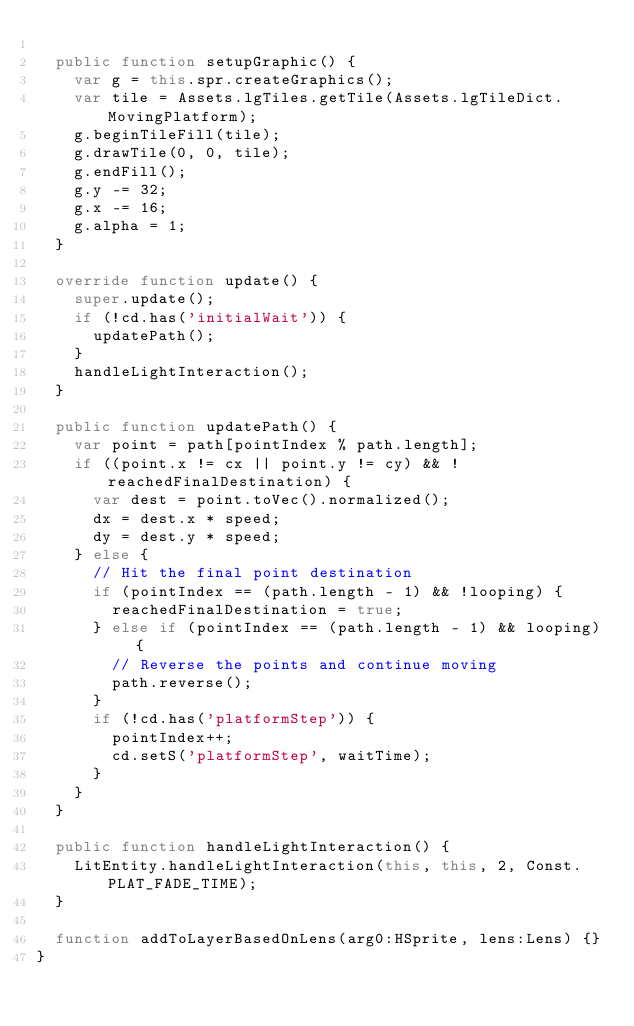Convert code to text. <code><loc_0><loc_0><loc_500><loc_500><_Haxe_>
  public function setupGraphic() {
    var g = this.spr.createGraphics();
    var tile = Assets.lgTiles.getTile(Assets.lgTileDict.MovingPlatform);
    g.beginTileFill(tile);
    g.drawTile(0, 0, tile);
    g.endFill();
    g.y -= 32;
    g.x -= 16;
    g.alpha = 1;
  }

  override function update() {
    super.update();
    if (!cd.has('initialWait')) {
      updatePath();
    }
    handleLightInteraction();
  }

  public function updatePath() {
    var point = path[pointIndex % path.length];
    if ((point.x != cx || point.y != cy) && !reachedFinalDestination) {
      var dest = point.toVec().normalized();
      dx = dest.x * speed;
      dy = dest.y * speed;
    } else {
      // Hit the final point destination
      if (pointIndex == (path.length - 1) && !looping) {
        reachedFinalDestination = true;
      } else if (pointIndex == (path.length - 1) && looping) {
        // Reverse the points and continue moving
        path.reverse();
      }
      if (!cd.has('platformStep')) {
        pointIndex++;
        cd.setS('platformStep', waitTime);
      }
    }
  }

  public function handleLightInteraction() {
    LitEntity.handleLightInteraction(this, this, 2, Const.PLAT_FADE_TIME);
  }

  function addToLayerBasedOnLens(arg0:HSprite, lens:Lens) {}
}</code> 